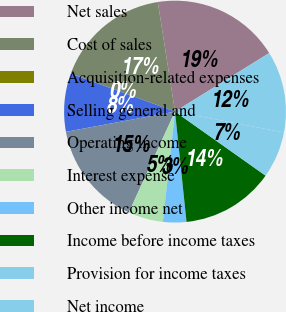<chart> <loc_0><loc_0><loc_500><loc_500><pie_chart><fcel>Net sales<fcel>Cost of sales<fcel>Acquisition-related expenses<fcel>Selling general and<fcel>Operating income<fcel>Interest expense<fcel>Other income net<fcel>Income before income taxes<fcel>Provision for income taxes<fcel>Net income<nl><fcel>18.63%<fcel>16.94%<fcel>0.02%<fcel>8.48%<fcel>15.25%<fcel>5.09%<fcel>3.4%<fcel>13.55%<fcel>6.79%<fcel>11.86%<nl></chart> 